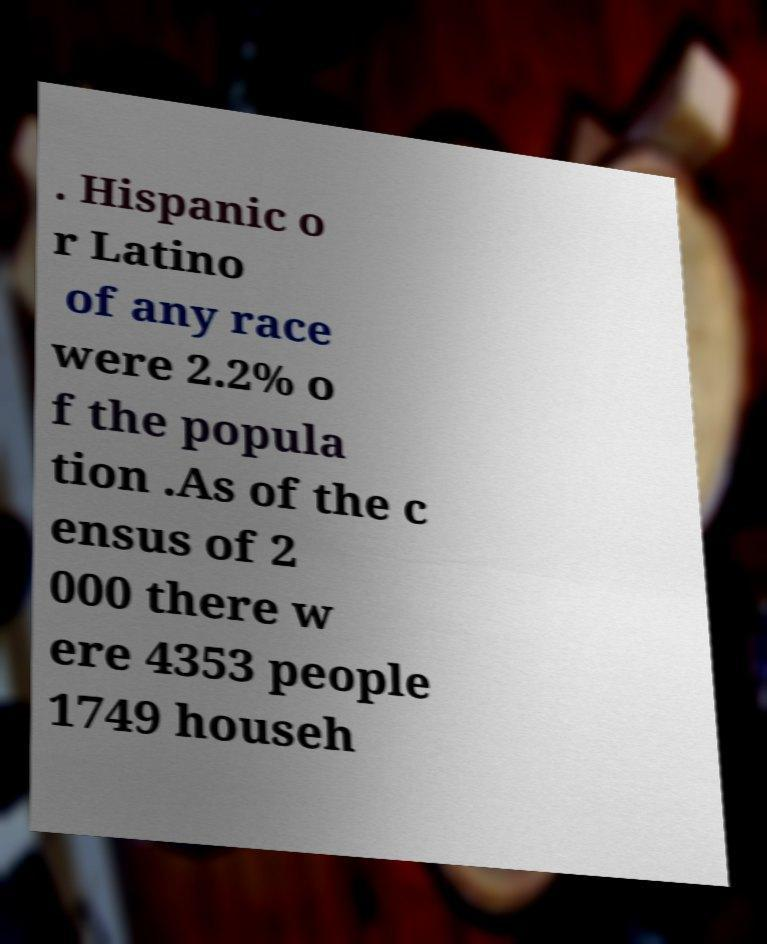For documentation purposes, I need the text within this image transcribed. Could you provide that? . Hispanic o r Latino of any race were 2.2% o f the popula tion .As of the c ensus of 2 000 there w ere 4353 people 1749 househ 